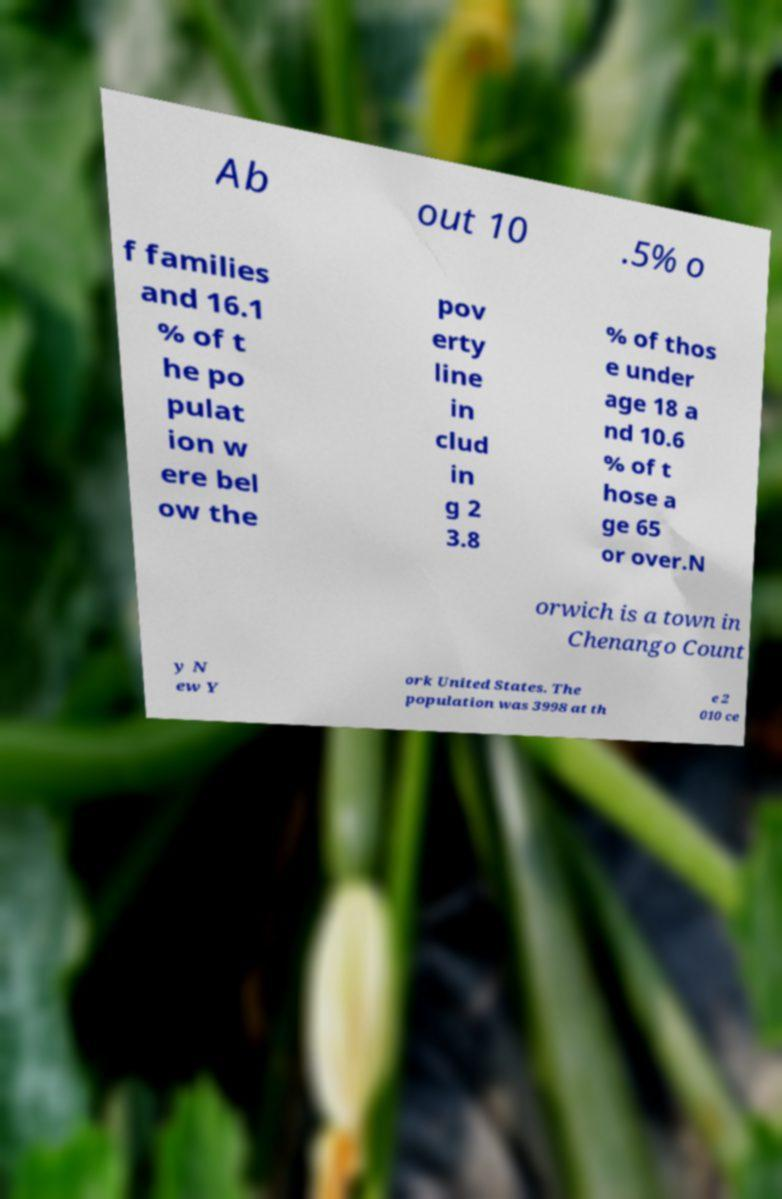Can you read and provide the text displayed in the image?This photo seems to have some interesting text. Can you extract and type it out for me? Ab out 10 .5% o f families and 16.1 % of t he po pulat ion w ere bel ow the pov erty line in clud in g 2 3.8 % of thos e under age 18 a nd 10.6 % of t hose a ge 65 or over.N orwich is a town in Chenango Count y N ew Y ork United States. The population was 3998 at th e 2 010 ce 